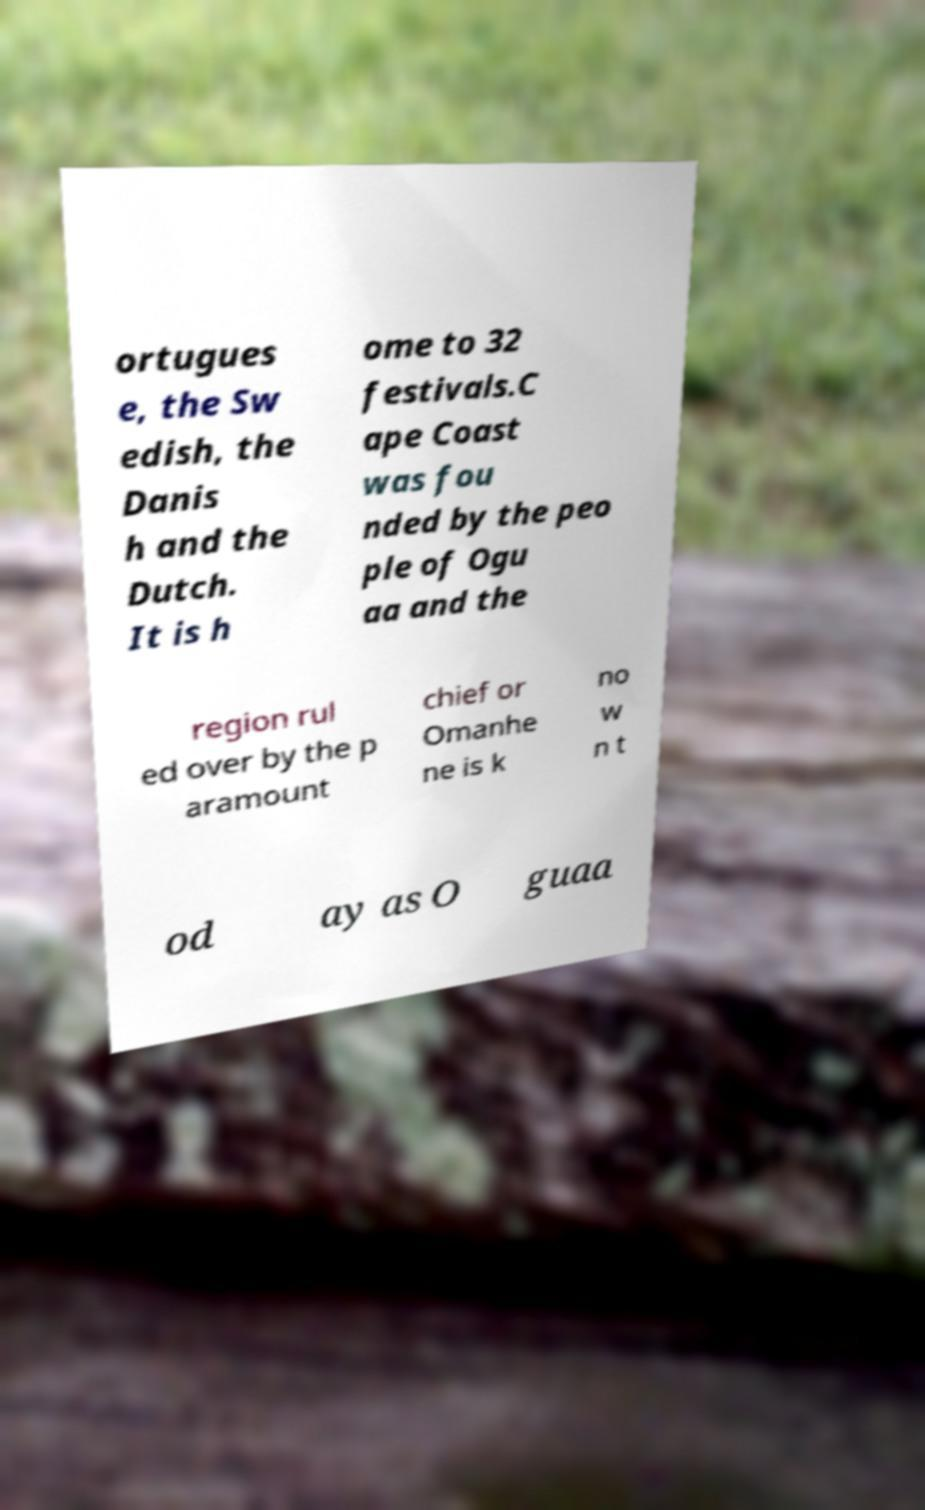What messages or text are displayed in this image? I need them in a readable, typed format. ortugues e, the Sw edish, the Danis h and the Dutch. It is h ome to 32 festivals.C ape Coast was fou nded by the peo ple of Ogu aa and the region rul ed over by the p aramount chief or Omanhe ne is k no w n t od ay as O guaa 